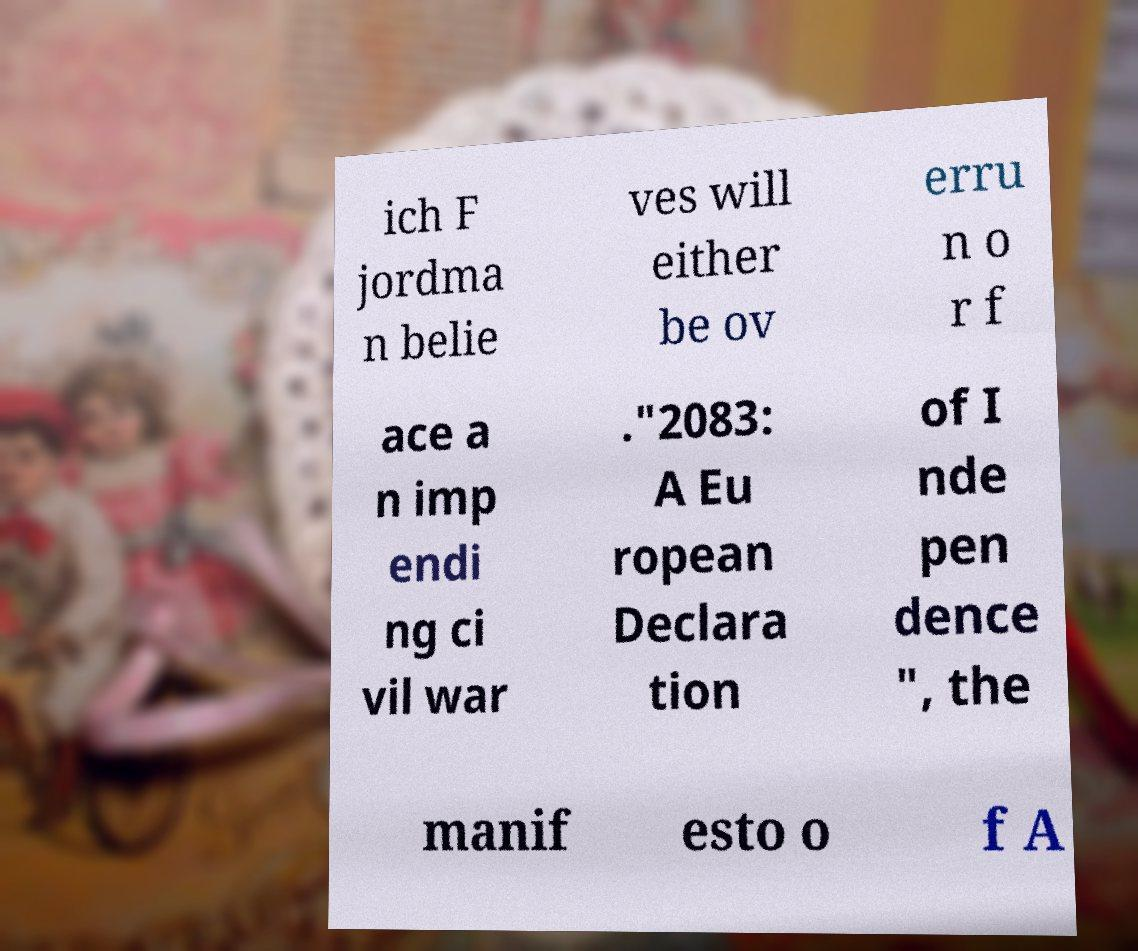For documentation purposes, I need the text within this image transcribed. Could you provide that? ich F jordma n belie ves will either be ov erru n o r f ace a n imp endi ng ci vil war ."2083: A Eu ropean Declara tion of I nde pen dence ", the manif esto o f A 